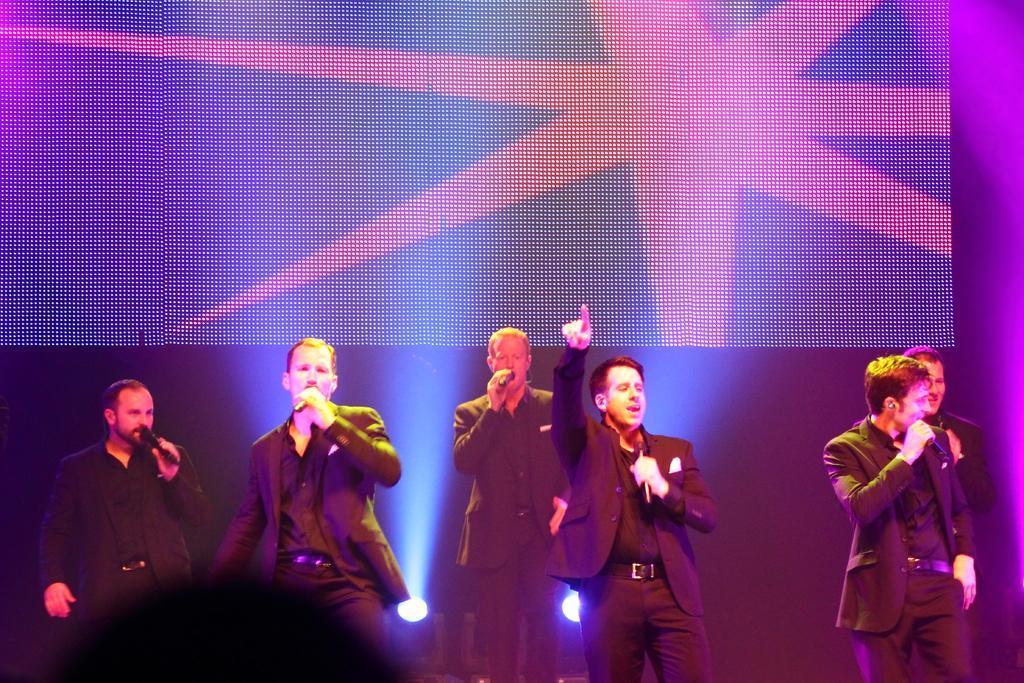Please provide a concise description of this image. In this image I can see group of people standing and they are holding microphones in their hands. In front the person is wearing black color dress, background I can see a screen and few lights. 